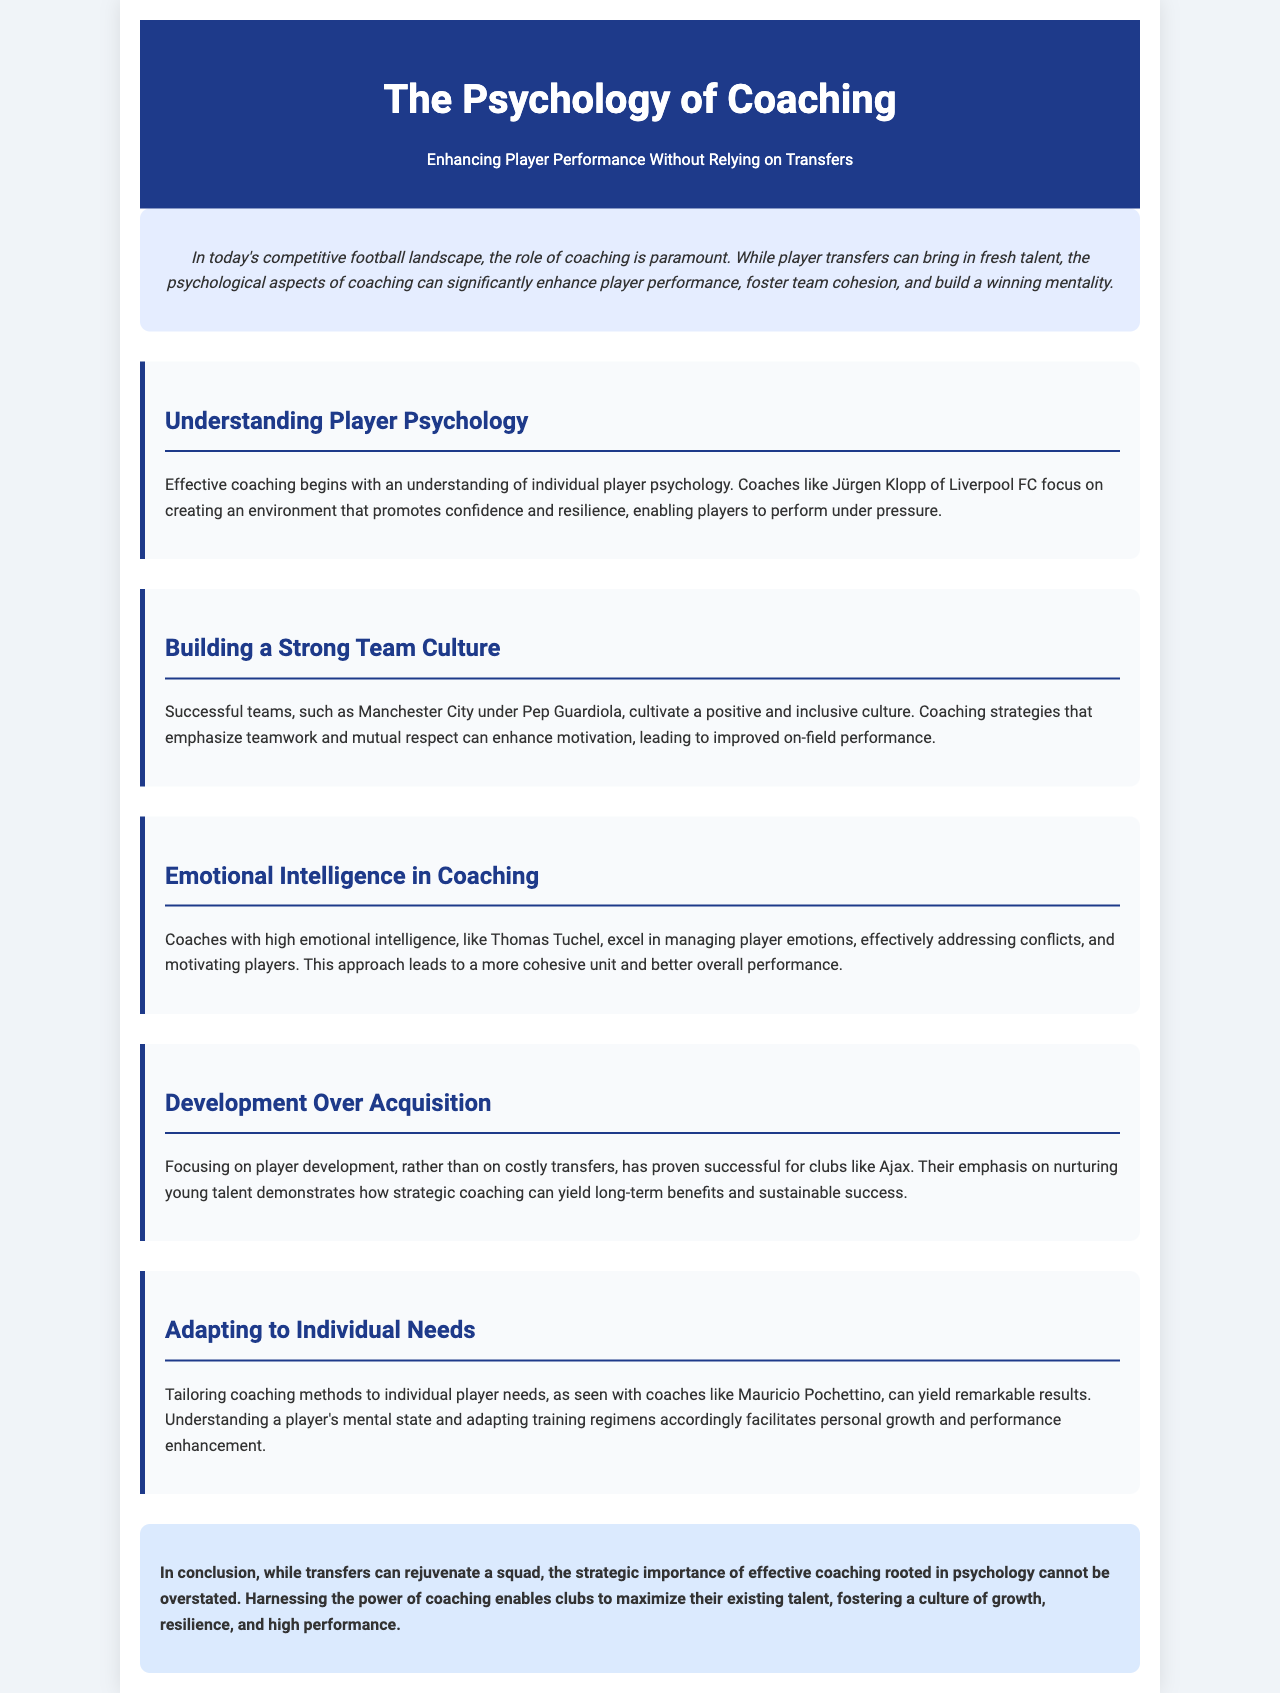What is the title of the brochure? The title is prominently displayed at the top of the document, which is "The Psychology of Coaching."
Answer: The Psychology of Coaching What is emphasized as a critical aspect of coaching in the introduction? The introduction highlights the psychological aspects of coaching as significantly enhancing player performance and team cohesion.
Answer: Psychological aspects Who is mentioned as an example of a coach focusing on player psychology? The document references Jürgen Klopp of Liverpool FC as an example of a coach who creates an environment that promotes confidence and resilience.
Answer: Jürgen Klopp Which club is cited as having success with a focus on player development? The club mentioned for its emphasis on nurturing young talent and focusing on player development is Ajax.
Answer: Ajax What key quality do coaches like Thomas Tuchel exhibit? The document states that coaches with high emotional intelligence excel at managing player emotions and conflicts.
Answer: Emotional intelligence What aspect does Pep Guardiola focus on to cultivate team culture? The section on building a strong team culture indicates that Pep Guardiola emphasizes teamwork and mutual respect.
Answer: Teamwork and mutual respect What outcome is mentioned as a benefit of tailoring coaching methods? The document indicates that tailoring coaching methods to individual needs leads to personal growth and performance enhancement.
Answer: Personal growth What does the conclusion stress about the importance of coaching? The conclusion emphasizes that the strategic importance of effective coaching rooted in psychology cannot be overstated.
Answer: Cannot be overstated 